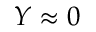Convert formula to latex. <formula><loc_0><loc_0><loc_500><loc_500>Y \approx 0</formula> 